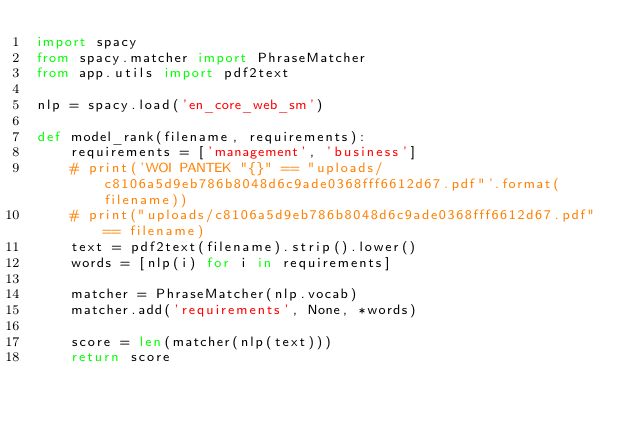Convert code to text. <code><loc_0><loc_0><loc_500><loc_500><_Python_>import spacy
from spacy.matcher import PhraseMatcher
from app.utils import pdf2text

nlp = spacy.load('en_core_web_sm')

def model_rank(filename, requirements):
    requirements = ['management', 'business']
    # print('WOI PANTEK "{}" == "uploads/c8106a5d9eb786b8048d6c9ade0368fff6612d67.pdf"'.format(filename))
    # print("uploads/c8106a5d9eb786b8048d6c9ade0368fff6612d67.pdf" == filename)
    text = pdf2text(filename).strip().lower()
    words = [nlp(i) for i in requirements]

    matcher = PhraseMatcher(nlp.vocab)
    matcher.add('requirements', None, *words)

    score = len(matcher(nlp(text)))
    return score
</code> 